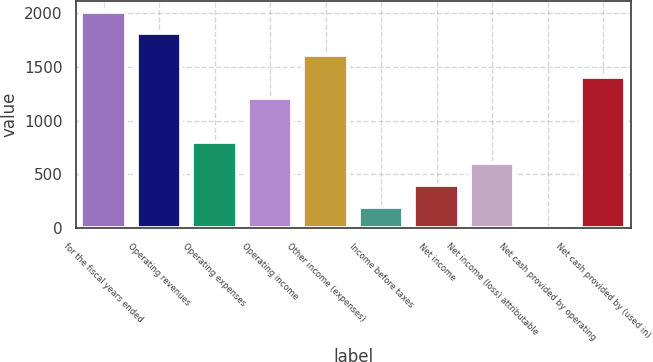<chart> <loc_0><loc_0><loc_500><loc_500><bar_chart><fcel>for the fiscal years ended<fcel>Operating revenues<fcel>Operating expenses<fcel>Operating income<fcel>Other income (expenses)<fcel>Income before taxes<fcel>Net income<fcel>Net income (loss) attributable<fcel>Net cash provided by operating<fcel>Net cash provided by (used in)<nl><fcel>2009<fcel>1808.19<fcel>804.14<fcel>1205.76<fcel>1607.38<fcel>201.71<fcel>402.52<fcel>603.33<fcel>0.9<fcel>1406.57<nl></chart> 